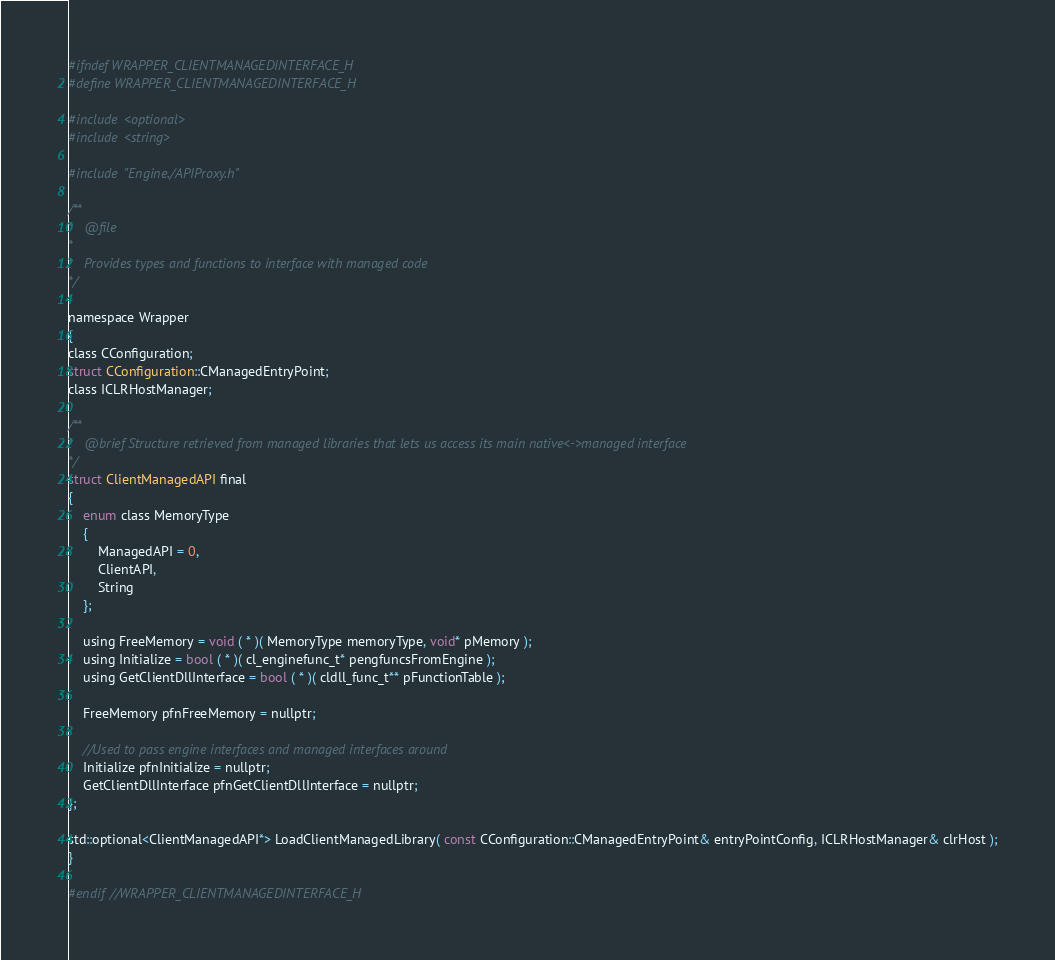<code> <loc_0><loc_0><loc_500><loc_500><_C_>#ifndef WRAPPER_CLIENTMANAGEDINTERFACE_H
#define WRAPPER_CLIENTMANAGEDINTERFACE_H

#include <optional>
#include <string>

#include "Engine./APIProxy.h"

/**
*	@file
*
*	Provides types and functions to interface with managed code
*/

namespace Wrapper
{
class CConfiguration;
struct CConfiguration::CManagedEntryPoint;
class ICLRHostManager;

/**
*	@brief Structure retrieved from managed libraries that lets us access its main native<->managed interface
*/
struct ClientManagedAPI final
{
	enum class MemoryType
	{
		ManagedAPI = 0,
		ClientAPI,
		String
	};

	using FreeMemory = void ( * )( MemoryType memoryType, void* pMemory );
	using Initialize = bool ( * )( cl_enginefunc_t* pengfuncsFromEngine );
	using GetClientDllInterface = bool ( * )( cldll_func_t** pFunctionTable );

	FreeMemory pfnFreeMemory = nullptr;

	//Used to pass engine interfaces and managed interfaces around
	Initialize pfnInitialize = nullptr;
	GetClientDllInterface pfnGetClientDllInterface = nullptr;
};

std::optional<ClientManagedAPI*> LoadClientManagedLibrary( const CConfiguration::CManagedEntryPoint& entryPointConfig, ICLRHostManager& clrHost );
}

#endif //WRAPPER_CLIENTMANAGEDINTERFACE_H
</code> 